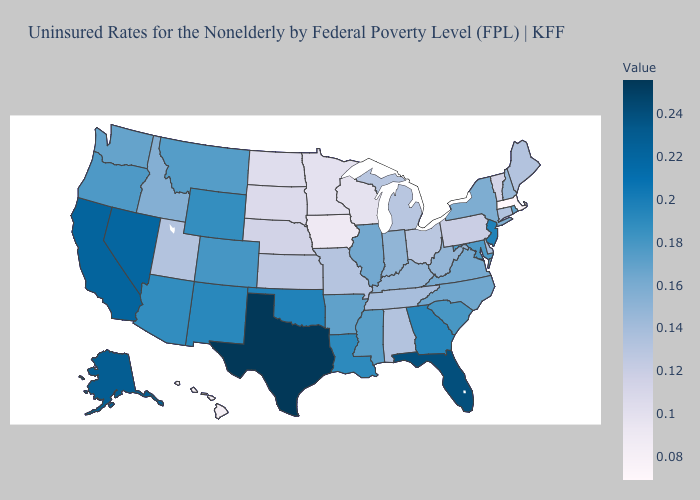Does New Hampshire have a higher value than Minnesota?
Quick response, please. Yes. Which states have the lowest value in the South?
Quick response, please. Alabama. Does Alabama have the lowest value in the South?
Be succinct. Yes. Among the states that border Arkansas , does Missouri have the lowest value?
Write a very short answer. Yes. Among the states that border Delaware , which have the highest value?
Keep it brief. New Jersey. 